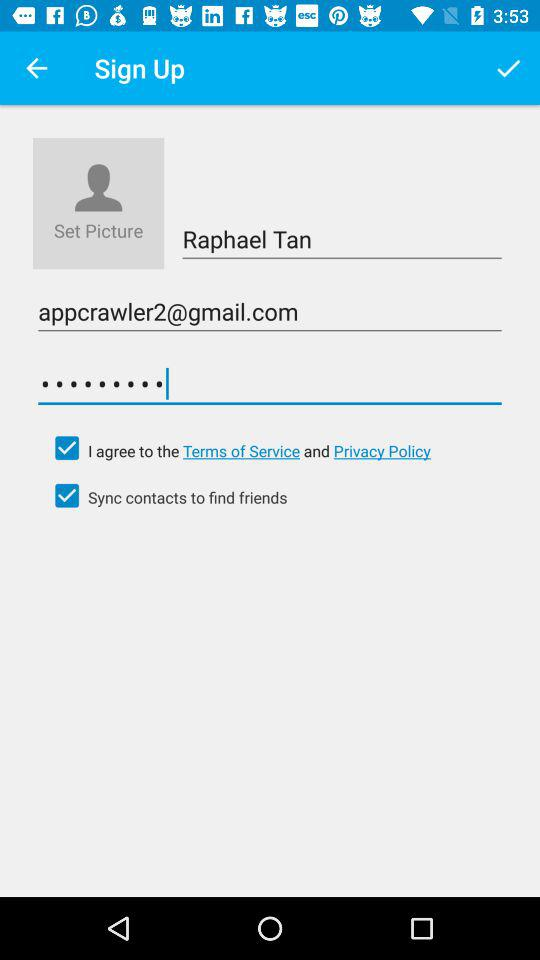How many characters are required for the password?
When the provided information is insufficient, respond with <no answer>. <no answer> 